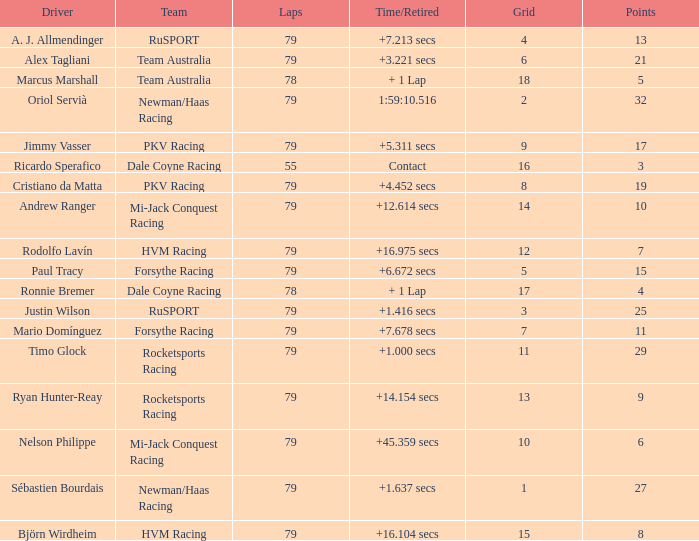Could you parse the entire table? {'header': ['Driver', 'Team', 'Laps', 'Time/Retired', 'Grid', 'Points'], 'rows': [['A. J. Allmendinger', 'RuSPORT', '79', '+7.213 secs', '4', '13'], ['Alex Tagliani', 'Team Australia', '79', '+3.221 secs', '6', '21'], ['Marcus Marshall', 'Team Australia', '78', '+ 1 Lap', '18', '5'], ['Oriol Servià', 'Newman/Haas Racing', '79', '1:59:10.516', '2', '32'], ['Jimmy Vasser', 'PKV Racing', '79', '+5.311 secs', '9', '17'], ['Ricardo Sperafico', 'Dale Coyne Racing', '55', 'Contact', '16', '3'], ['Cristiano da Matta', 'PKV Racing', '79', '+4.452 secs', '8', '19'], ['Andrew Ranger', 'Mi-Jack Conquest Racing', '79', '+12.614 secs', '14', '10'], ['Rodolfo Lavín', 'HVM Racing', '79', '+16.975 secs', '12', '7'], ['Paul Tracy', 'Forsythe Racing', '79', '+6.672 secs', '5', '15'], ['Ronnie Bremer', 'Dale Coyne Racing', '78', '+ 1 Lap', '17', '4'], ['Justin Wilson', 'RuSPORT', '79', '+1.416 secs', '3', '25'], ['Mario Domínguez', 'Forsythe Racing', '79', '+7.678 secs', '7', '11'], ['Timo Glock', 'Rocketsports Racing', '79', '+1.000 secs', '11', '29'], ['Ryan Hunter-Reay', 'Rocketsports Racing', '79', '+14.154 secs', '13', '9'], ['Nelson Philippe', 'Mi-Jack Conquest Racing', '79', '+45.359 secs', '10', '6'], ['Sébastien Bourdais', 'Newman/Haas Racing', '79', '+1.637 secs', '1', '27'], ['Björn Wirdheim', 'HVM Racing', '79', '+16.104 secs', '15', '8']]} Which points has the driver Paul Tracy? 15.0. 